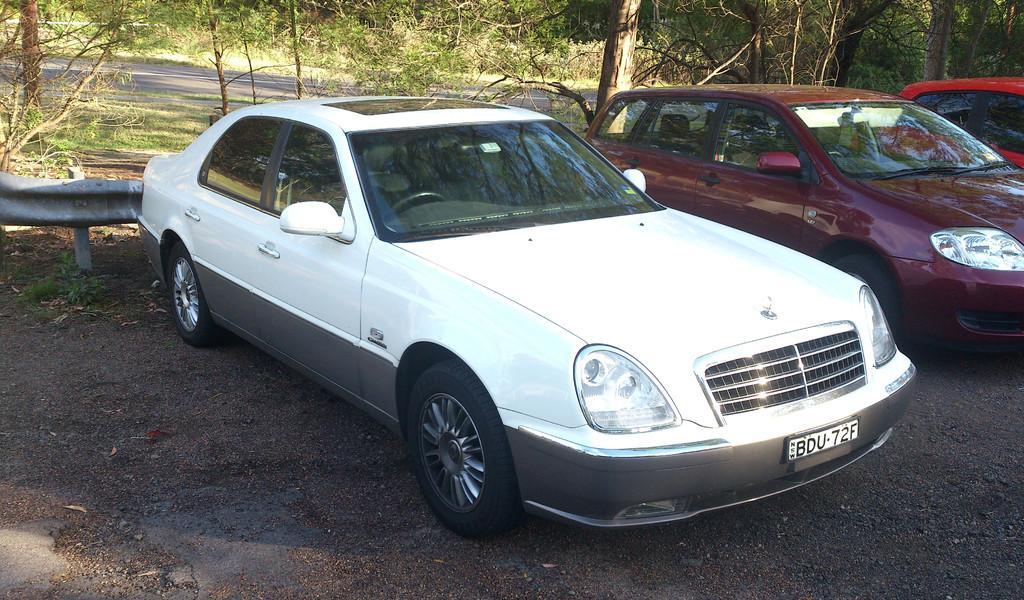How would you summarize this image in a sentence or two? There are 3 cars on the road. There is a road and trees are present at the back. 